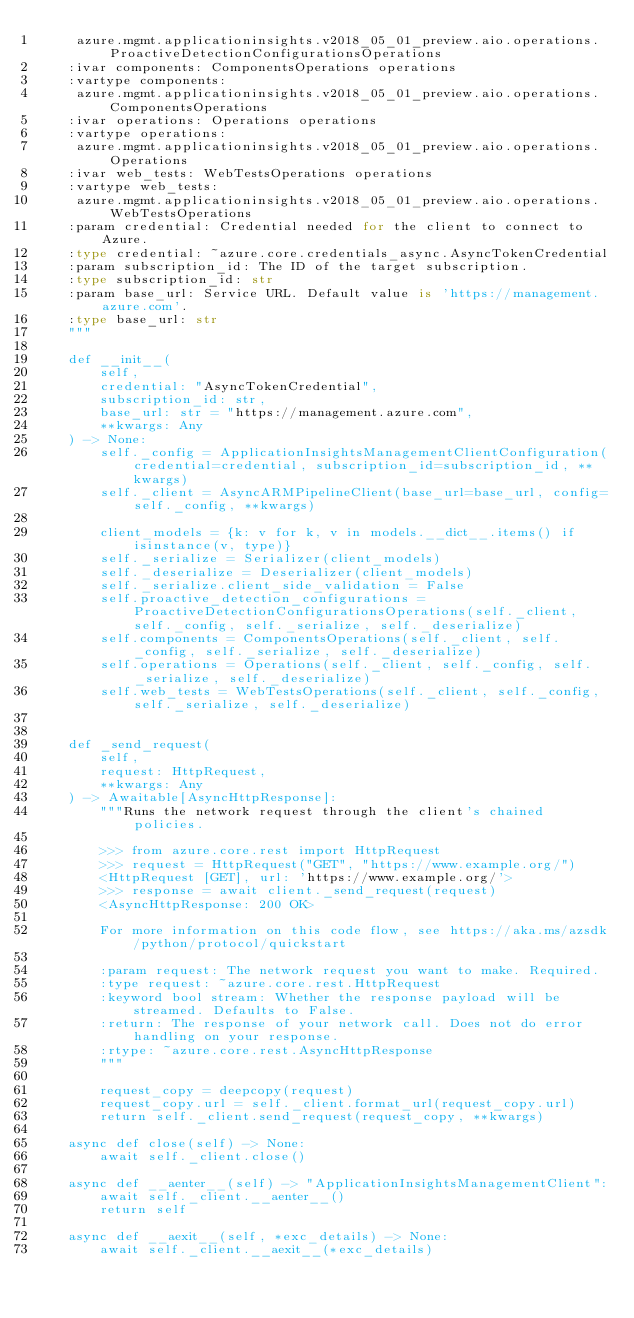Convert code to text. <code><loc_0><loc_0><loc_500><loc_500><_Python_>     azure.mgmt.applicationinsights.v2018_05_01_preview.aio.operations.ProactiveDetectionConfigurationsOperations
    :ivar components: ComponentsOperations operations
    :vartype components:
     azure.mgmt.applicationinsights.v2018_05_01_preview.aio.operations.ComponentsOperations
    :ivar operations: Operations operations
    :vartype operations:
     azure.mgmt.applicationinsights.v2018_05_01_preview.aio.operations.Operations
    :ivar web_tests: WebTestsOperations operations
    :vartype web_tests:
     azure.mgmt.applicationinsights.v2018_05_01_preview.aio.operations.WebTestsOperations
    :param credential: Credential needed for the client to connect to Azure.
    :type credential: ~azure.core.credentials_async.AsyncTokenCredential
    :param subscription_id: The ID of the target subscription.
    :type subscription_id: str
    :param base_url: Service URL. Default value is 'https://management.azure.com'.
    :type base_url: str
    """

    def __init__(
        self,
        credential: "AsyncTokenCredential",
        subscription_id: str,
        base_url: str = "https://management.azure.com",
        **kwargs: Any
    ) -> None:
        self._config = ApplicationInsightsManagementClientConfiguration(credential=credential, subscription_id=subscription_id, **kwargs)
        self._client = AsyncARMPipelineClient(base_url=base_url, config=self._config, **kwargs)

        client_models = {k: v for k, v in models.__dict__.items() if isinstance(v, type)}
        self._serialize = Serializer(client_models)
        self._deserialize = Deserializer(client_models)
        self._serialize.client_side_validation = False
        self.proactive_detection_configurations = ProactiveDetectionConfigurationsOperations(self._client, self._config, self._serialize, self._deserialize)
        self.components = ComponentsOperations(self._client, self._config, self._serialize, self._deserialize)
        self.operations = Operations(self._client, self._config, self._serialize, self._deserialize)
        self.web_tests = WebTestsOperations(self._client, self._config, self._serialize, self._deserialize)


    def _send_request(
        self,
        request: HttpRequest,
        **kwargs: Any
    ) -> Awaitable[AsyncHttpResponse]:
        """Runs the network request through the client's chained policies.

        >>> from azure.core.rest import HttpRequest
        >>> request = HttpRequest("GET", "https://www.example.org/")
        <HttpRequest [GET], url: 'https://www.example.org/'>
        >>> response = await client._send_request(request)
        <AsyncHttpResponse: 200 OK>

        For more information on this code flow, see https://aka.ms/azsdk/python/protocol/quickstart

        :param request: The network request you want to make. Required.
        :type request: ~azure.core.rest.HttpRequest
        :keyword bool stream: Whether the response payload will be streamed. Defaults to False.
        :return: The response of your network call. Does not do error handling on your response.
        :rtype: ~azure.core.rest.AsyncHttpResponse
        """

        request_copy = deepcopy(request)
        request_copy.url = self._client.format_url(request_copy.url)
        return self._client.send_request(request_copy, **kwargs)

    async def close(self) -> None:
        await self._client.close()

    async def __aenter__(self) -> "ApplicationInsightsManagementClient":
        await self._client.__aenter__()
        return self

    async def __aexit__(self, *exc_details) -> None:
        await self._client.__aexit__(*exc_details)
</code> 